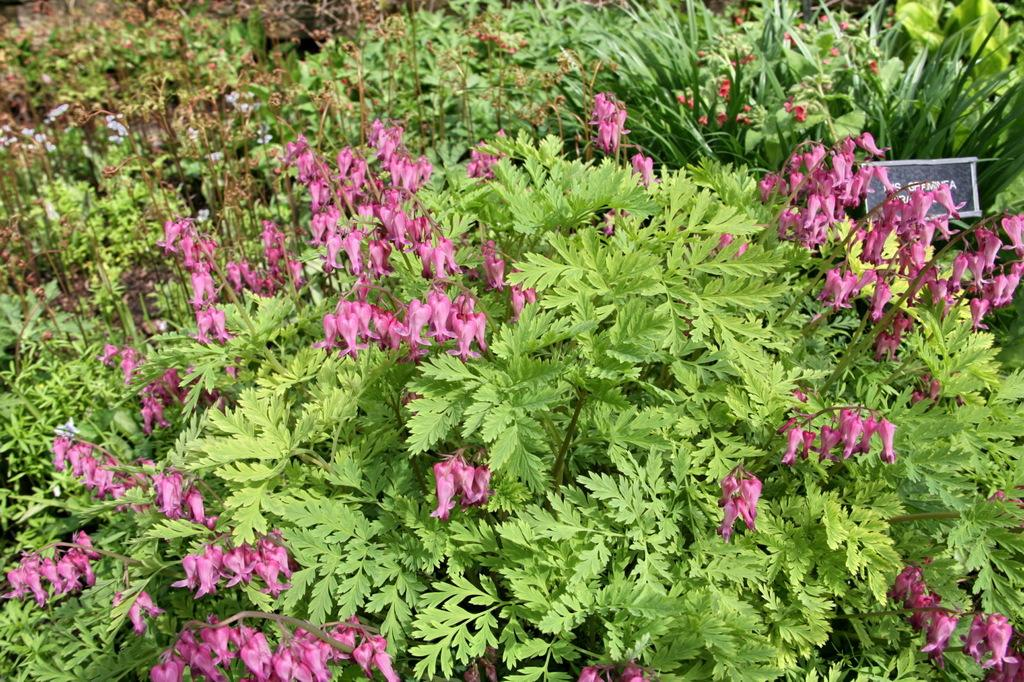What type of living organisms can be seen in the image? Plants and flowers are visible in the image. Can you describe the board on the right side of the image? Yes, there is a board on the right side of the image. What is the primary difference between the plants and flowers in the image? The plants and flowers are different in that the flowers are typically more colorful and have a distinct shape compared to the plants. What type of yarn is being used to create the slope in the image? There is no slope or yarn present in the image. 